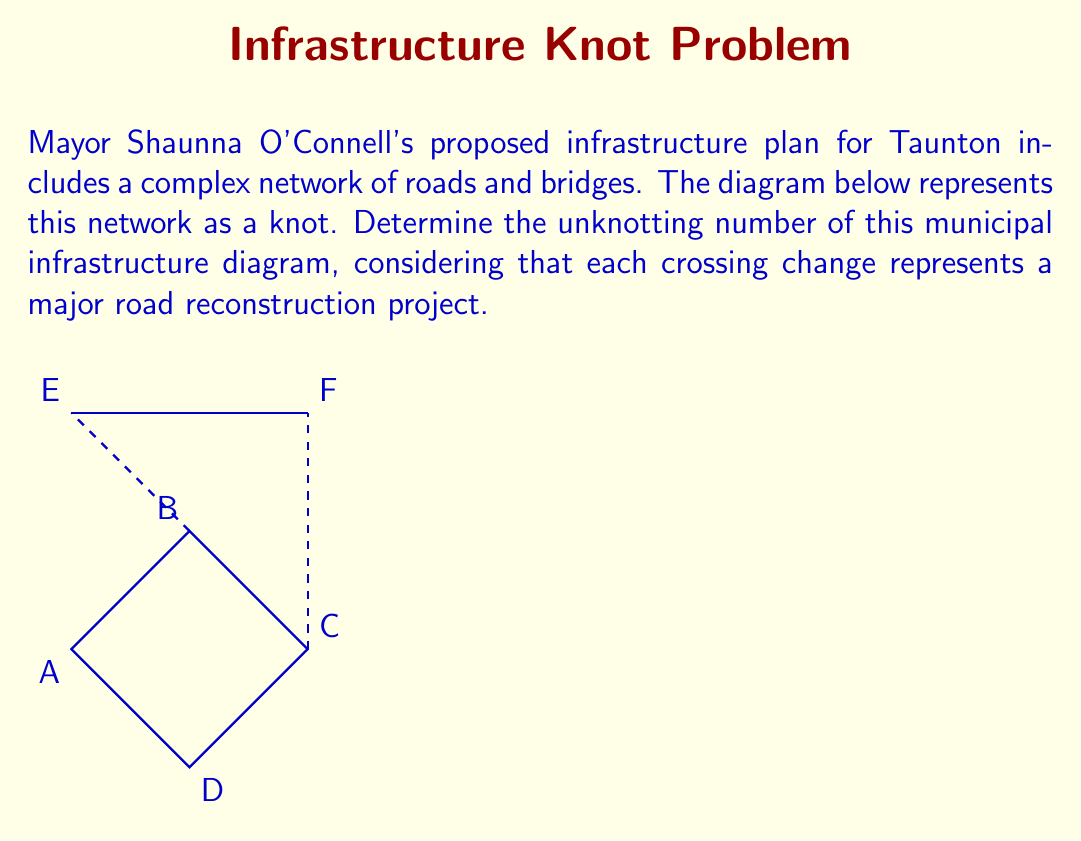Can you answer this question? To determine the unknotting number of this municipal infrastructure diagram, we need to follow these steps:

1) First, let's identify the crossings in the diagram. We can see that there are two crossings: one where BE crosses AC, and another where CF crosses AD.

2) The unknotting number is the minimum number of crossing changes needed to transform the knot into an unknot (a simple closed curve with no crossings).

3) Let's analyze each crossing:
   a) At the BE-AC crossing, if we change this crossing, we can pull BE over to the right side of the diagram.
   b) At the CF-AD crossing, changing this will allow us to pull CF to the left side.

4) After making these two changes, we can see that the diagram can be deformed into a simple closed curve without any crossings.

5) It's important to note that changing just one crossing is not sufficient to unknot this diagram. We need both changes to fully simplify the infrastructure network.

6) Therefore, the unknotting number for this municipal infrastructure diagram is 2.

In the context of Mayor O'Connell's infrastructure plan, this means that a minimum of two major road reconstruction projects would be necessary to simplify the road network to its most basic form.
Answer: 2 